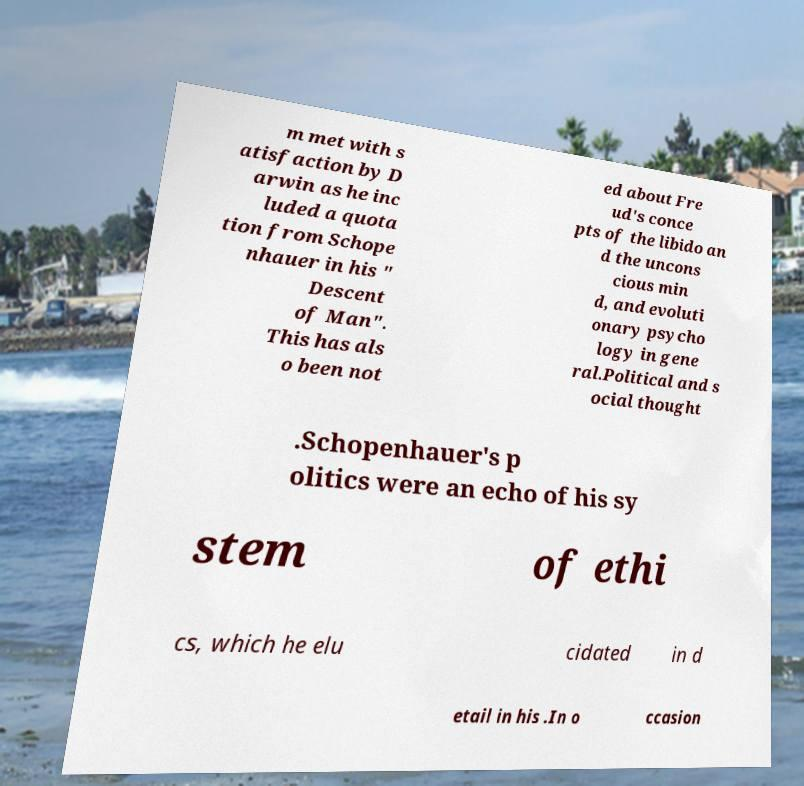Can you read and provide the text displayed in the image?This photo seems to have some interesting text. Can you extract and type it out for me? m met with s atisfaction by D arwin as he inc luded a quota tion from Schope nhauer in his " Descent of Man". This has als o been not ed about Fre ud's conce pts of the libido an d the uncons cious min d, and evoluti onary psycho logy in gene ral.Political and s ocial thought .Schopenhauer's p olitics were an echo of his sy stem of ethi cs, which he elu cidated in d etail in his .In o ccasion 